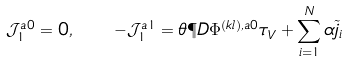Convert formula to latex. <formula><loc_0><loc_0><loc_500><loc_500>\mathcal { J } _ { 1 } ^ { a 0 } = 0 , \quad - \mathcal { J } _ { 1 } ^ { a 1 } = \theta \P D { \Phi ^ { ( k l ) , a 0 } } { \tau _ { V } } + \sum _ { i = 1 } ^ { N } \alpha \tilde { j } _ { i }</formula> 